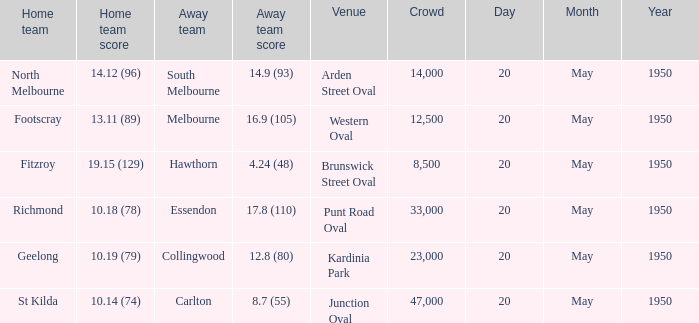Could you parse the entire table as a dict? {'header': ['Home team', 'Home team score', 'Away team', 'Away team score', 'Venue', 'Crowd', 'Day', 'Month', 'Year'], 'rows': [['North Melbourne', '14.12 (96)', 'South Melbourne', '14.9 (93)', 'Arden Street Oval', '14,000', '20', 'May', '1950'], ['Footscray', '13.11 (89)', 'Melbourne', '16.9 (105)', 'Western Oval', '12,500', '20', 'May', '1950'], ['Fitzroy', '19.15 (129)', 'Hawthorn', '4.24 (48)', 'Brunswick Street Oval', '8,500', '20', 'May', '1950'], ['Richmond', '10.18 (78)', 'Essendon', '17.8 (110)', 'Punt Road Oval', '33,000', '20', 'May', '1950'], ['Geelong', '10.19 (79)', 'Collingwood', '12.8 (80)', 'Kardinia Park', '23,000', '20', 'May', '1950'], ['St Kilda', '10.14 (74)', 'Carlton', '8.7 (55)', 'Junction Oval', '47,000', '20', 'May', '1950']]} What was the score for the away team when the home team was Fitzroy? 4.24 (48). 